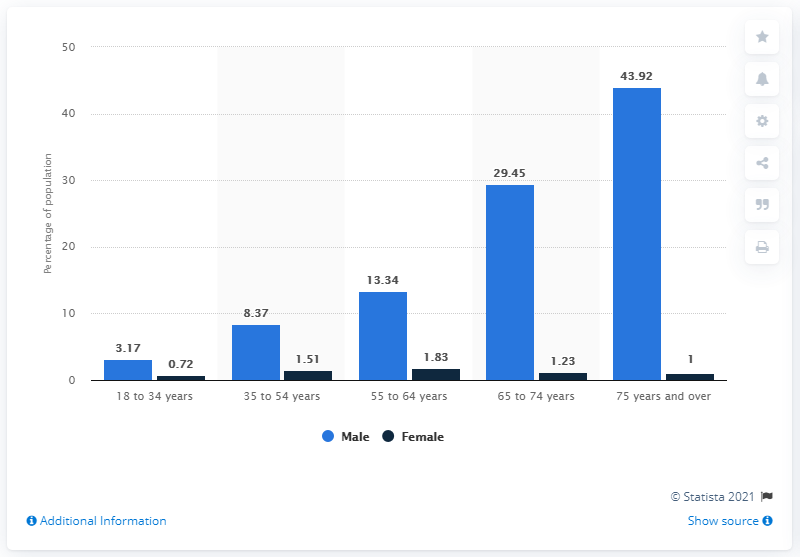Indicate a few pertinent items in this graphic. In 2019, approximately 43.92% of male Americans aged 75 years and over were veterans. The age group with the highest number of male veterans is 75 years and over. The difference between the male and female veterans as a percentage of the US population is the least among those in the age group of 18 to 34 years old. 